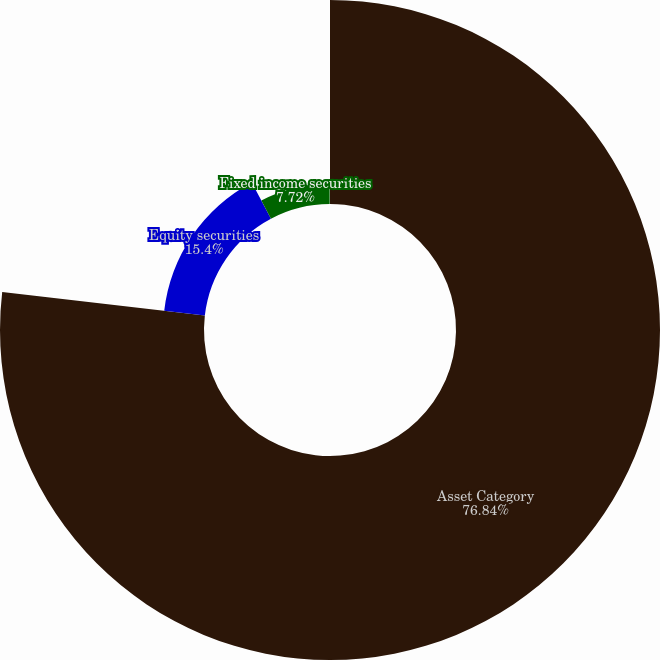Convert chart to OTSL. <chart><loc_0><loc_0><loc_500><loc_500><pie_chart><fcel>Asset Category<fcel>Equity securities<fcel>Fixed income securities<fcel>Cash and other investments<nl><fcel>76.84%<fcel>15.4%<fcel>7.72%<fcel>0.04%<nl></chart> 